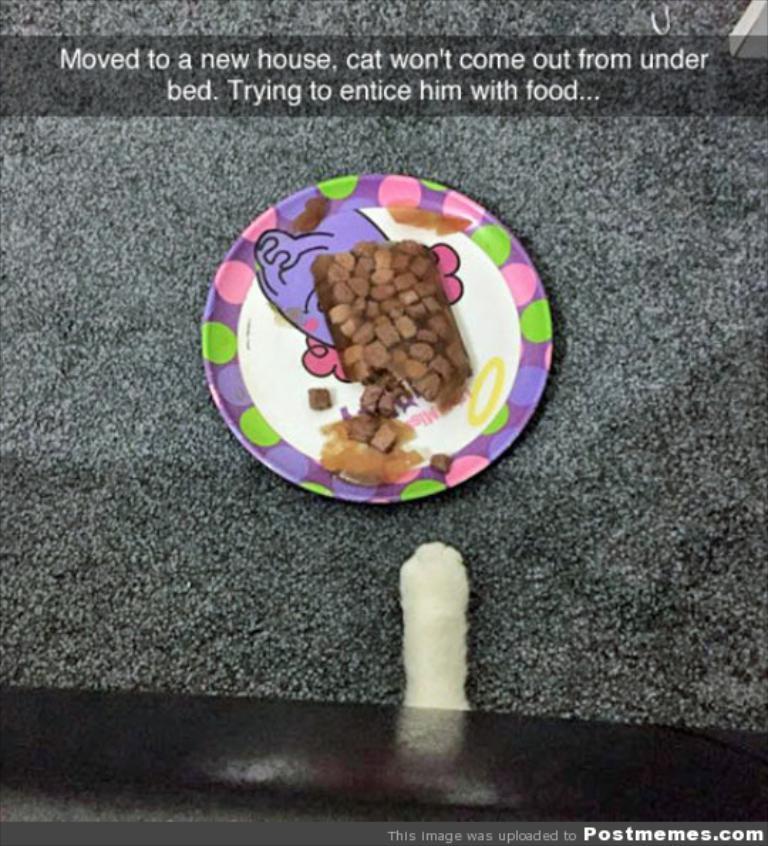Describe this image in one or two sentences. In the center of the image we can see a plate containing food is placed on the surface. At the bottom of the image we can see leg of an animal. At the top of the image we can see some text.= 